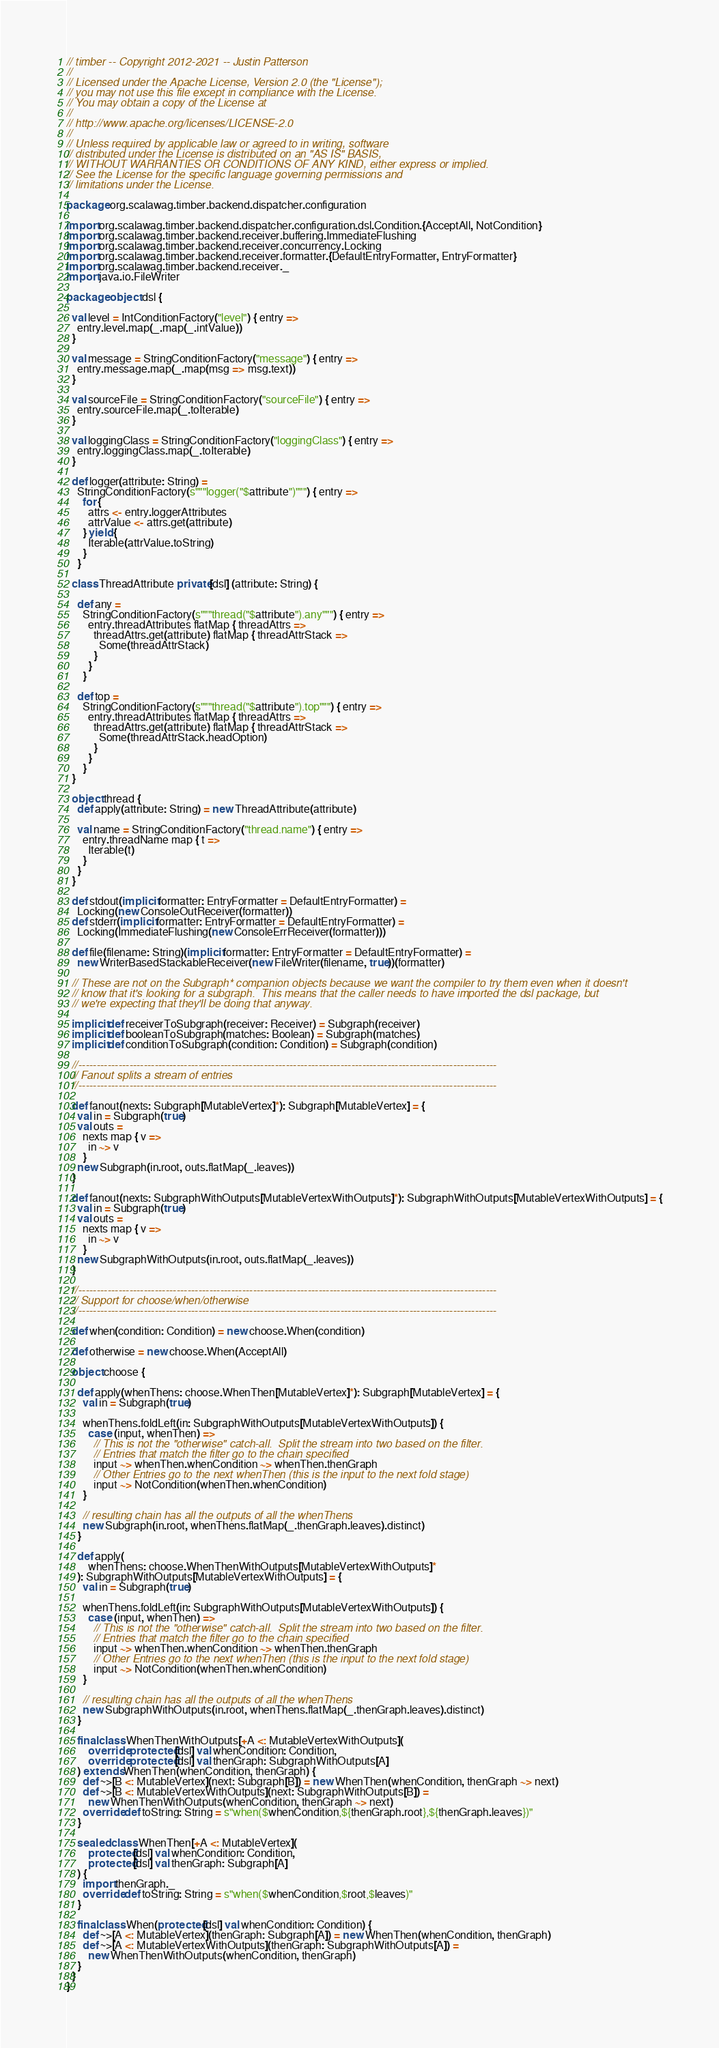Convert code to text. <code><loc_0><loc_0><loc_500><loc_500><_Scala_>// timber -- Copyright 2012-2021 -- Justin Patterson
//
// Licensed under the Apache License, Version 2.0 (the "License");
// you may not use this file except in compliance with the License.
// You may obtain a copy of the License at
//
// http://www.apache.org/licenses/LICENSE-2.0
//
// Unless required by applicable law or agreed to in writing, software
// distributed under the License is distributed on an "AS IS" BASIS,
// WITHOUT WARRANTIES OR CONDITIONS OF ANY KIND, either express or implied.
// See the License for the specific language governing permissions and
// limitations under the License.

package org.scalawag.timber.backend.dispatcher.configuration

import org.scalawag.timber.backend.dispatcher.configuration.dsl.Condition.{AcceptAll, NotCondition}
import org.scalawag.timber.backend.receiver.buffering.ImmediateFlushing
import org.scalawag.timber.backend.receiver.concurrency.Locking
import org.scalawag.timber.backend.receiver.formatter.{DefaultEntryFormatter, EntryFormatter}
import org.scalawag.timber.backend.receiver._
import java.io.FileWriter

package object dsl {

  val level = IntConditionFactory("level") { entry =>
    entry.level.map(_.map(_.intValue))
  }

  val message = StringConditionFactory("message") { entry =>
    entry.message.map(_.map(msg => msg.text))
  }

  val sourceFile = StringConditionFactory("sourceFile") { entry =>
    entry.sourceFile.map(_.toIterable)
  }

  val loggingClass = StringConditionFactory("loggingClass") { entry =>
    entry.loggingClass.map(_.toIterable)
  }

  def logger(attribute: String) =
    StringConditionFactory(s"""logger("$attribute")""") { entry =>
      for {
        attrs <- entry.loggerAttributes
        attrValue <- attrs.get(attribute)
      } yield {
        Iterable(attrValue.toString)
      }
    }

  class ThreadAttribute private[dsl] (attribute: String) {

    def any =
      StringConditionFactory(s"""thread("$attribute").any""") { entry =>
        entry.threadAttributes flatMap { threadAttrs =>
          threadAttrs.get(attribute) flatMap { threadAttrStack =>
            Some(threadAttrStack)
          }
        }
      }

    def top =
      StringConditionFactory(s"""thread("$attribute").top""") { entry =>
        entry.threadAttributes flatMap { threadAttrs =>
          threadAttrs.get(attribute) flatMap { threadAttrStack =>
            Some(threadAttrStack.headOption)
          }
        }
      }
  }

  object thread {
    def apply(attribute: String) = new ThreadAttribute(attribute)

    val name = StringConditionFactory("thread.name") { entry =>
      entry.threadName map { t =>
        Iterable(t)
      }
    }
  }

  def stdout(implicit formatter: EntryFormatter = DefaultEntryFormatter) =
    Locking(new ConsoleOutReceiver(formatter))
  def stderr(implicit formatter: EntryFormatter = DefaultEntryFormatter) =
    Locking(ImmediateFlushing(new ConsoleErrReceiver(formatter)))

  def file(filename: String)(implicit formatter: EntryFormatter = DefaultEntryFormatter) =
    new WriterBasedStackableReceiver(new FileWriter(filename, true))(formatter)

  // These are not on the Subgraph* companion objects because we want the compiler to try them even when it doesn't
  // know that it's looking for a subgraph.  This means that the caller needs to have imported the dsl package, but
  // we're expecting that they'll be doing that anyway.

  implicit def receiverToSubgraph(receiver: Receiver) = Subgraph(receiver)
  implicit def booleanToSubgraph(matches: Boolean) = Subgraph(matches)
  implicit def conditionToSubgraph(condition: Condition) = Subgraph(condition)

  //-------------------------------------------------------------------------------------------------------------------
  // Fanout splits a stream of entries
  //-------------------------------------------------------------------------------------------------------------------

  def fanout(nexts: Subgraph[MutableVertex]*): Subgraph[MutableVertex] = {
    val in = Subgraph(true)
    val outs =
      nexts map { v =>
        in ~> v
      }
    new Subgraph(in.root, outs.flatMap(_.leaves))
  }

  def fanout(nexts: SubgraphWithOutputs[MutableVertexWithOutputs]*): SubgraphWithOutputs[MutableVertexWithOutputs] = {
    val in = Subgraph(true)
    val outs =
      nexts map { v =>
        in ~> v
      }
    new SubgraphWithOutputs(in.root, outs.flatMap(_.leaves))
  }

  //-------------------------------------------------------------------------------------------------------------------
  // Support for choose/when/otherwise
  //-------------------------------------------------------------------------------------------------------------------

  def when(condition: Condition) = new choose.When(condition)

  def otherwise = new choose.When(AcceptAll)

  object choose {

    def apply(whenThens: choose.WhenThen[MutableVertex]*): Subgraph[MutableVertex] = {
      val in = Subgraph(true)

      whenThens.foldLeft(in: SubgraphWithOutputs[MutableVertexWithOutputs]) {
        case (input, whenThen) =>
          // This is not the "otherwise" catch-all.  Split the stream into two based on the filter.
          // Entries that match the filter go to the chain specified
          input ~> whenThen.whenCondition ~> whenThen.thenGraph
          // Other Entries go to the next whenThen (this is the input to the next fold stage)
          input ~> NotCondition(whenThen.whenCondition)
      }

      // resulting chain has all the outputs of all the whenThens
      new Subgraph(in.root, whenThens.flatMap(_.thenGraph.leaves).distinct)
    }

    def apply(
        whenThens: choose.WhenThenWithOutputs[MutableVertexWithOutputs]*
    ): SubgraphWithOutputs[MutableVertexWithOutputs] = {
      val in = Subgraph(true)

      whenThens.foldLeft(in: SubgraphWithOutputs[MutableVertexWithOutputs]) {
        case (input, whenThen) =>
          // This is not the "otherwise" catch-all.  Split the stream into two based on the filter.
          // Entries that match the filter go to the chain specified
          input ~> whenThen.whenCondition ~> whenThen.thenGraph
          // Other Entries go to the next whenThen (this is the input to the next fold stage)
          input ~> NotCondition(whenThen.whenCondition)
      }

      // resulting chain has all the outputs of all the whenThens
      new SubgraphWithOutputs(in.root, whenThens.flatMap(_.thenGraph.leaves).distinct)
    }

    final class WhenThenWithOutputs[+A <: MutableVertexWithOutputs](
        override protected[dsl] val whenCondition: Condition,
        override protected[dsl] val thenGraph: SubgraphWithOutputs[A]
    ) extends WhenThen(whenCondition, thenGraph) {
      def ~>[B <: MutableVertex](next: Subgraph[B]) = new WhenThen(whenCondition, thenGraph ~> next)
      def ~>[B <: MutableVertexWithOutputs](next: SubgraphWithOutputs[B]) =
        new WhenThenWithOutputs(whenCondition, thenGraph ~> next)
      override def toString: String = s"when($whenCondition,${thenGraph.root},${thenGraph.leaves})"
    }

    sealed class WhenThen[+A <: MutableVertex](
        protected[dsl] val whenCondition: Condition,
        protected[dsl] val thenGraph: Subgraph[A]
    ) {
      import thenGraph._
      override def toString: String = s"when($whenCondition,$root,$leaves)"
    }

    final class When(protected[dsl] val whenCondition: Condition) {
      def ~>[A <: MutableVertex](thenGraph: Subgraph[A]) = new WhenThen(whenCondition, thenGraph)
      def ~>[A <: MutableVertexWithOutputs](thenGraph: SubgraphWithOutputs[A]) =
        new WhenThenWithOutputs(whenCondition, thenGraph)
    }
  }
}
</code> 